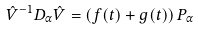Convert formula to latex. <formula><loc_0><loc_0><loc_500><loc_500>\hat { V } ^ { - 1 } D _ { \alpha } \hat { V } = \left ( f ( t ) + g ( t ) \right ) P _ { \alpha }</formula> 